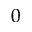Convert formula to latex. <formula><loc_0><loc_0><loc_500><loc_500>0</formula> 